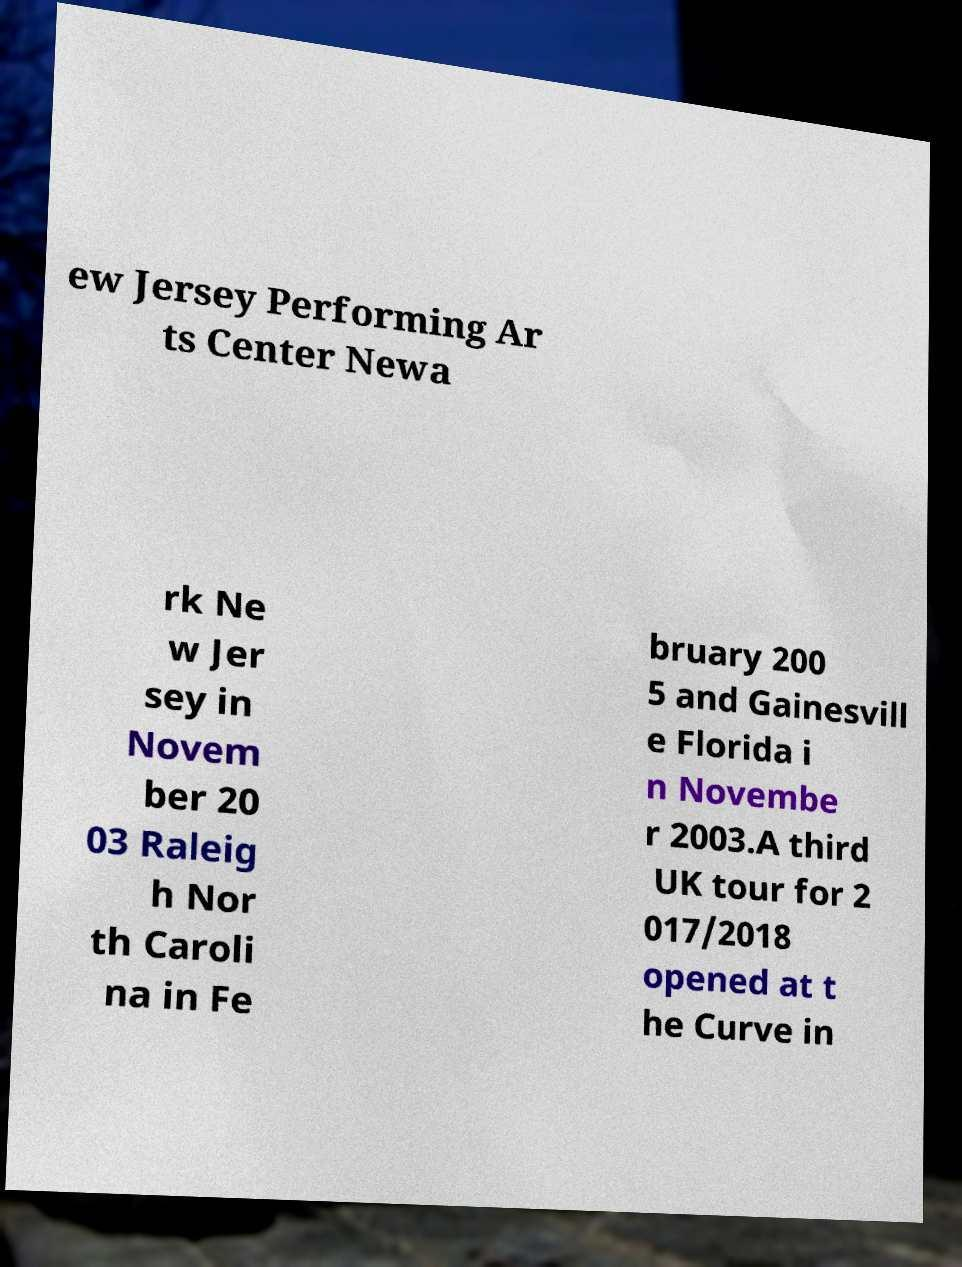Can you read and provide the text displayed in the image?This photo seems to have some interesting text. Can you extract and type it out for me? ew Jersey Performing Ar ts Center Newa rk Ne w Jer sey in Novem ber 20 03 Raleig h Nor th Caroli na in Fe bruary 200 5 and Gainesvill e Florida i n Novembe r 2003.A third UK tour for 2 017/2018 opened at t he Curve in 